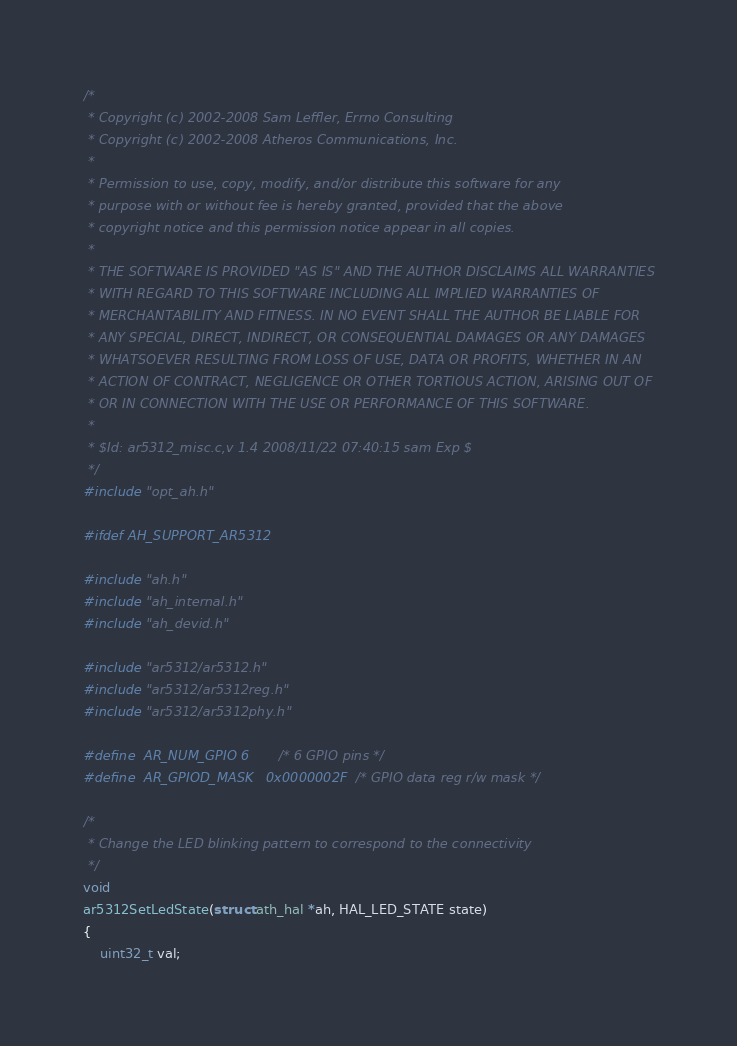Convert code to text. <code><loc_0><loc_0><loc_500><loc_500><_C_>/*
 * Copyright (c) 2002-2008 Sam Leffler, Errno Consulting
 * Copyright (c) 2002-2008 Atheros Communications, Inc.
 *
 * Permission to use, copy, modify, and/or distribute this software for any
 * purpose with or without fee is hereby granted, provided that the above
 * copyright notice and this permission notice appear in all copies.
 *
 * THE SOFTWARE IS PROVIDED "AS IS" AND THE AUTHOR DISCLAIMS ALL WARRANTIES
 * WITH REGARD TO THIS SOFTWARE INCLUDING ALL IMPLIED WARRANTIES OF
 * MERCHANTABILITY AND FITNESS. IN NO EVENT SHALL THE AUTHOR BE LIABLE FOR
 * ANY SPECIAL, DIRECT, INDIRECT, OR CONSEQUENTIAL DAMAGES OR ANY DAMAGES
 * WHATSOEVER RESULTING FROM LOSS OF USE, DATA OR PROFITS, WHETHER IN AN
 * ACTION OF CONTRACT, NEGLIGENCE OR OTHER TORTIOUS ACTION, ARISING OUT OF
 * OR IN CONNECTION WITH THE USE OR PERFORMANCE OF THIS SOFTWARE.
 *
 * $Id: ar5312_misc.c,v 1.4 2008/11/22 07:40:15 sam Exp $
 */
#include "opt_ah.h"

#ifdef AH_SUPPORT_AR5312

#include "ah.h"
#include "ah_internal.h"
#include "ah_devid.h"

#include "ar5312/ar5312.h"
#include "ar5312/ar5312reg.h"
#include "ar5312/ar5312phy.h"

#define	AR_NUM_GPIO	6		/* 6 GPIO pins */
#define	AR_GPIOD_MASK	0x0000002F	/* GPIO data reg r/w mask */

/*
 * Change the LED blinking pattern to correspond to the connectivity
 */
void
ar5312SetLedState(struct ath_hal *ah, HAL_LED_STATE state)
{
	uint32_t val;</code> 